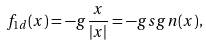Convert formula to latex. <formula><loc_0><loc_0><loc_500><loc_500>f _ { 1 d } ( x ) = - g \frac { x } { | x | } = - g s g n ( x ) ,</formula> 